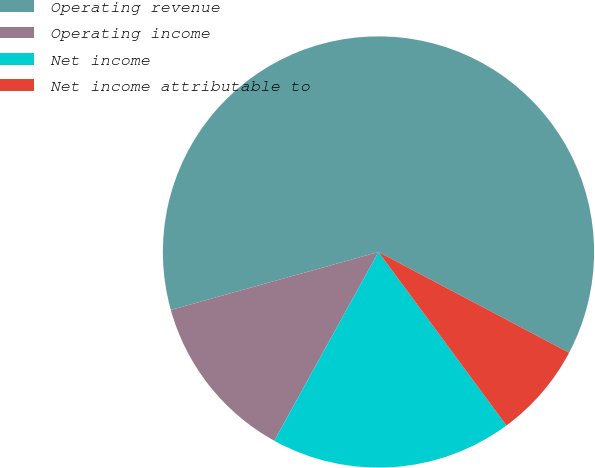Convert chart to OTSL. <chart><loc_0><loc_0><loc_500><loc_500><pie_chart><fcel>Operating revenue<fcel>Operating income<fcel>Net income<fcel>Net income attributable to<nl><fcel>62.07%<fcel>12.64%<fcel>18.14%<fcel>7.15%<nl></chart> 